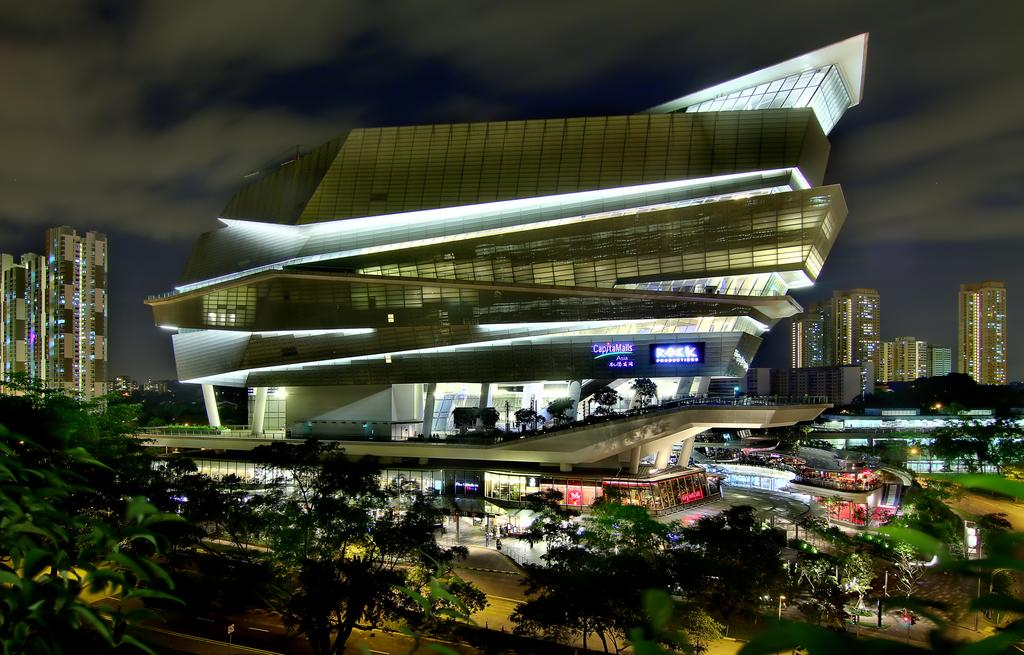What type of structures can be seen in the image? There are buildings in the image. What other natural elements are present in the image? There are trees in the image. What is at the bottom of the image? There is a road visible at the bottom of the image. What is visible at the top of the image? The sky is visible at the top of the image. What can be observed in the sky? Clouds are present in the sky. Can you tell me how many matches are being used to light the buildings in the image? There are no matches present in the image, and the buildings are not being lit by any matches. 